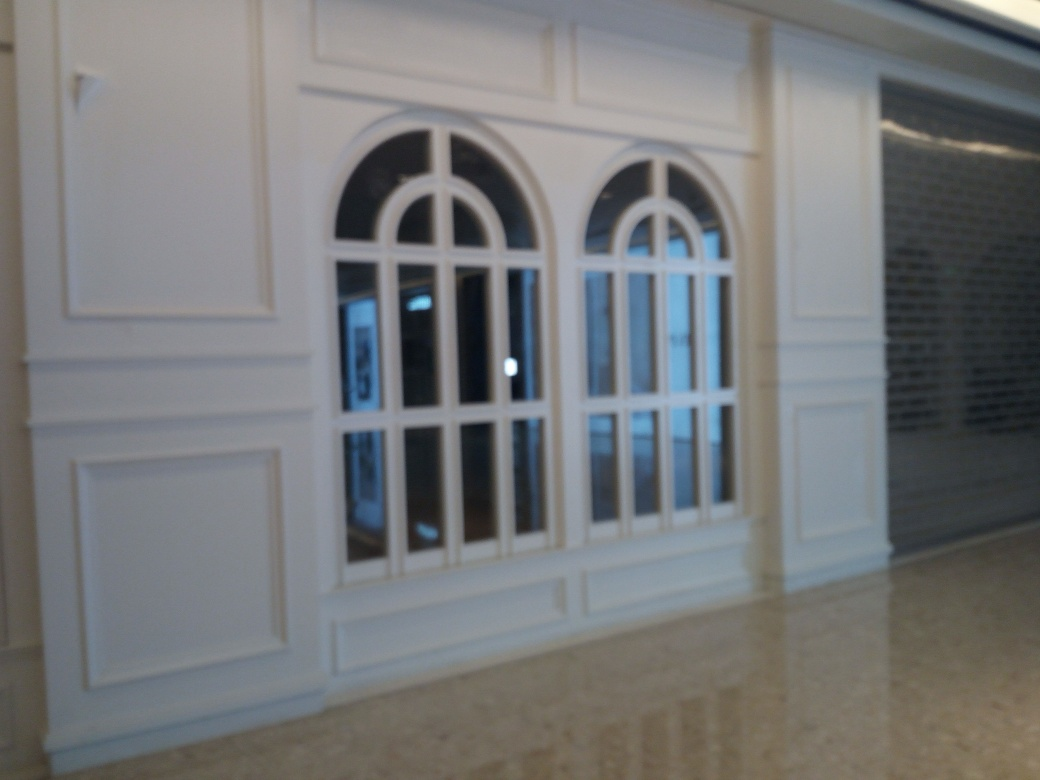What time of day does it seem to be outside? It is difficult to ascertain the exact time of day due to the camera's exposure settings and the focus issue, but it appears to be daylight outside given the brightness visible through the windows. 